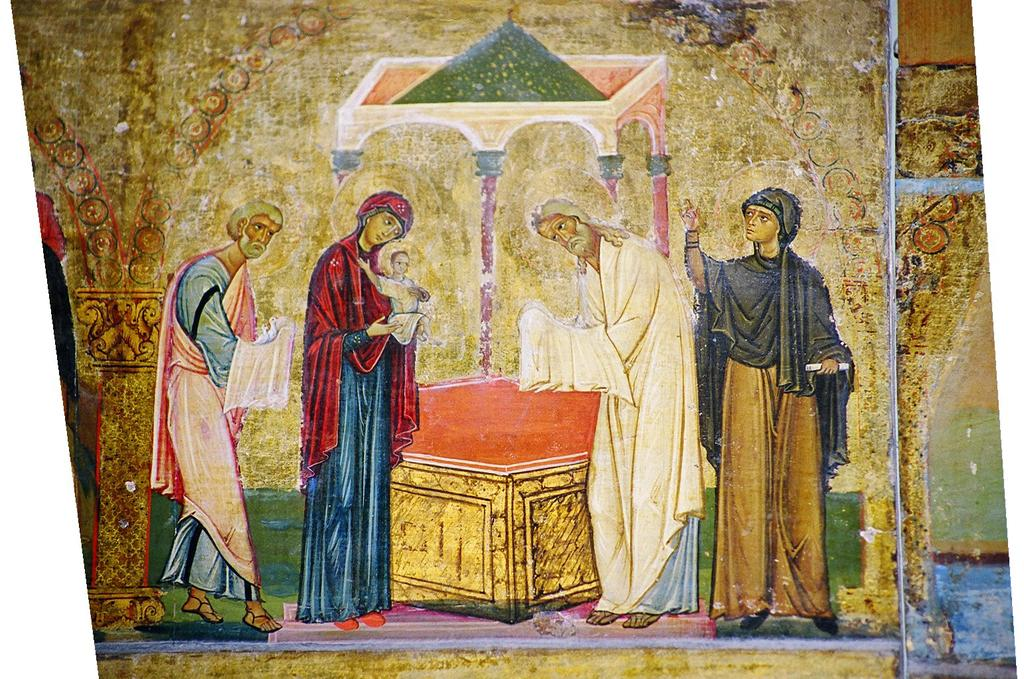What type of artwork is depicted in the image? The image is a painting. Can you describe the subjects in the painting? There are persons and objects in the painting. Are there any additional elements in the background of the painting? Yes, there are other objects in the background of the painting. What is the surface on which the subjects and objects are placed in the painting? There is a floor at the bottom of the painting. What type of grass is growing on the floor in the painting? There is no grass present in the painting; the floor is a surface for the subjects and objects. 